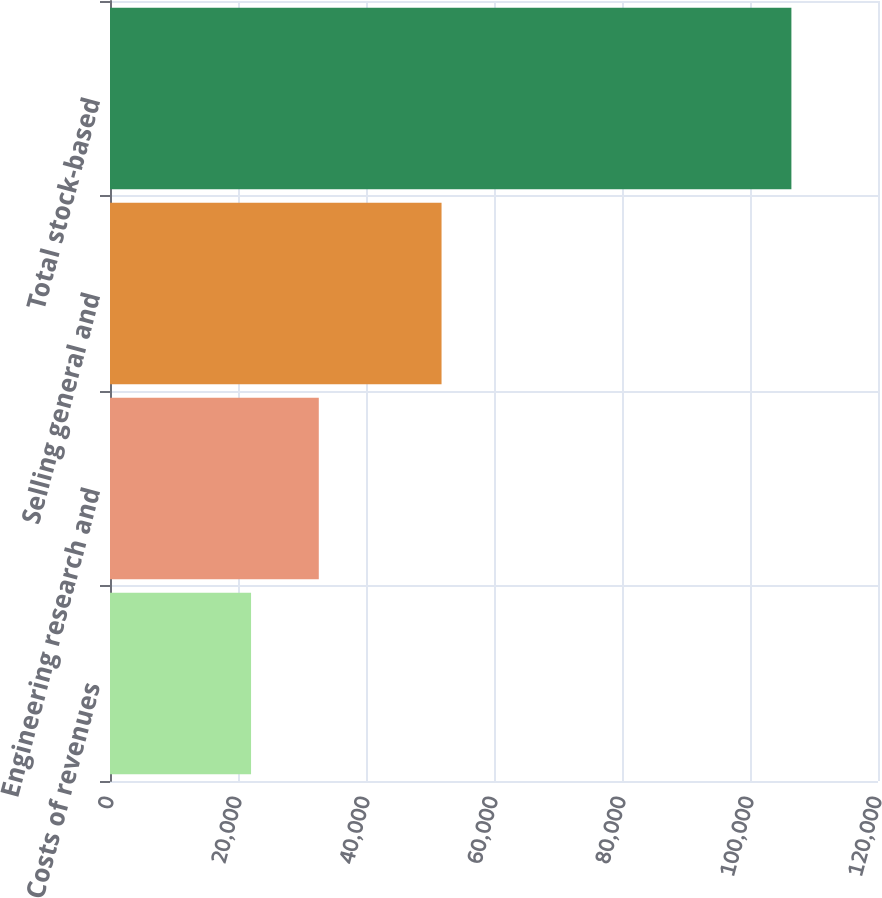Convert chart to OTSL. <chart><loc_0><loc_0><loc_500><loc_500><bar_chart><fcel>Costs of revenues<fcel>Engineering research and<fcel>Selling general and<fcel>Total stock-based<nl><fcel>22041<fcel>32623<fcel>51804<fcel>106468<nl></chart> 